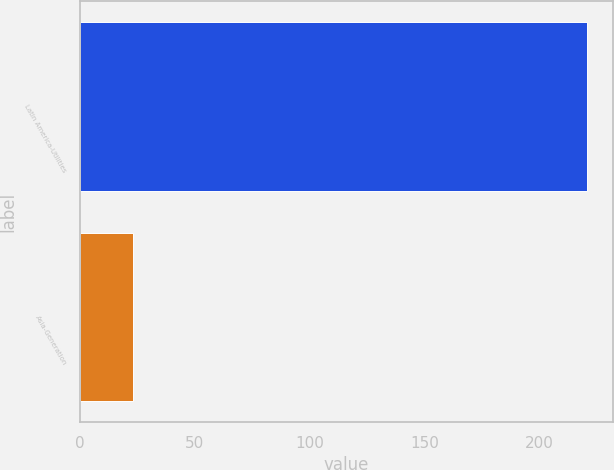Convert chart. <chart><loc_0><loc_0><loc_500><loc_500><bar_chart><fcel>Latin America-Utilities<fcel>Asia-Generation<nl><fcel>221<fcel>23<nl></chart> 